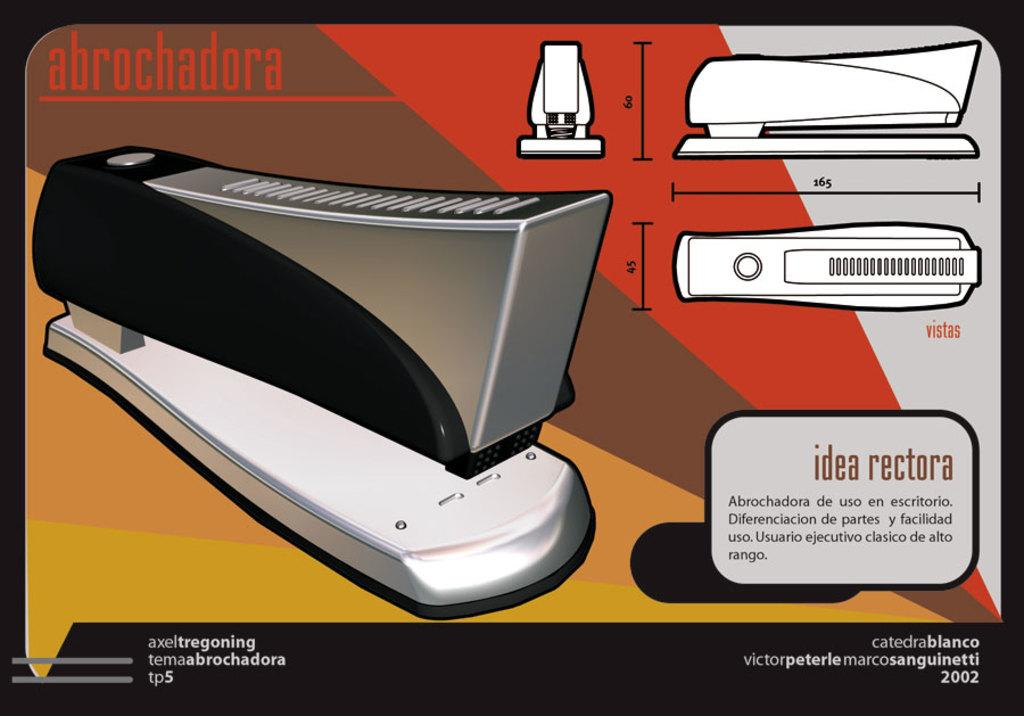<image>
Write a terse but informative summary of the picture. Picture showing a staple and the name abrochadora as well as the different angles. 